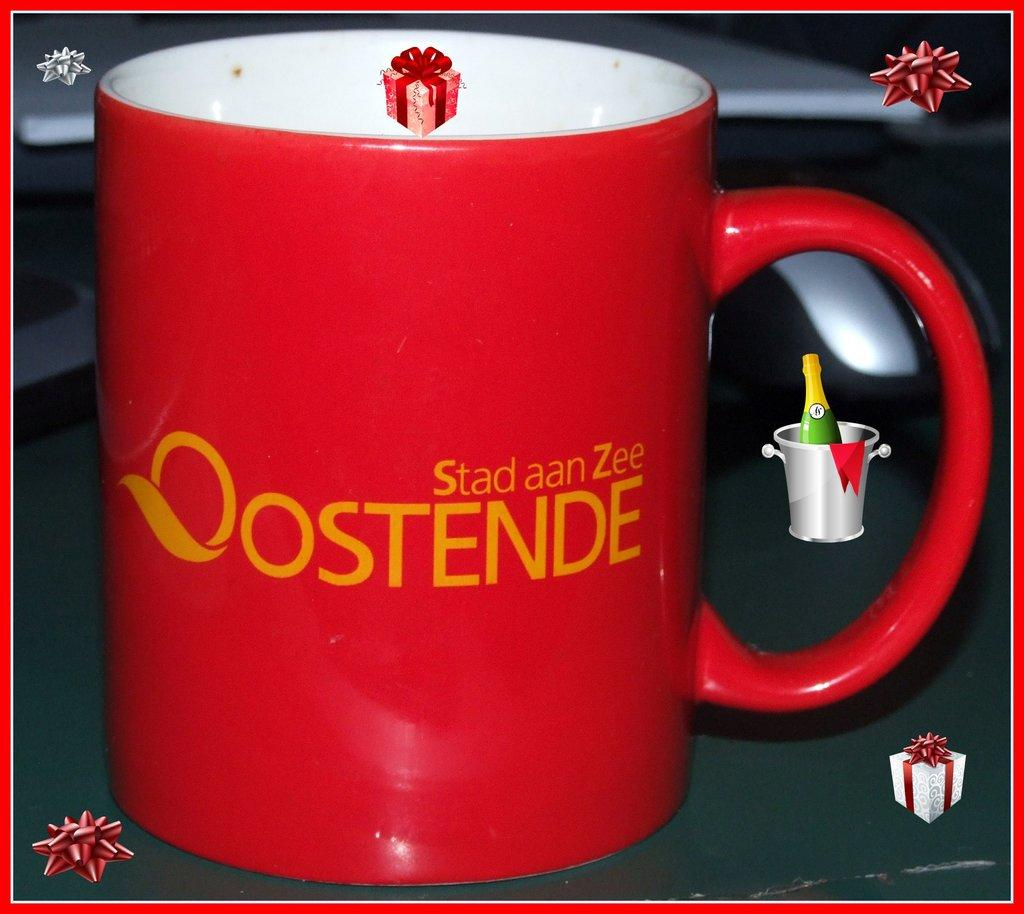What is present in the image that people typically use for drinking? There is a coffee cup in the image. What color is the coffee cup? The coffee cup is red in color. What can be seen on the coffee cup besides its color? There is text on the coffee cup, and the text is yellow in color. Are there any additional features on the coffee cup? Yes, there are watermarks visible on the coffee cup. How many bikes are parked next to the coffee cup in the image? There are no bikes present in the image; it only features a coffee cup. What type of quilt is covering the coffee cup in the image? There is no quilt present in the image; the coffee cup is not covered by any fabric. 